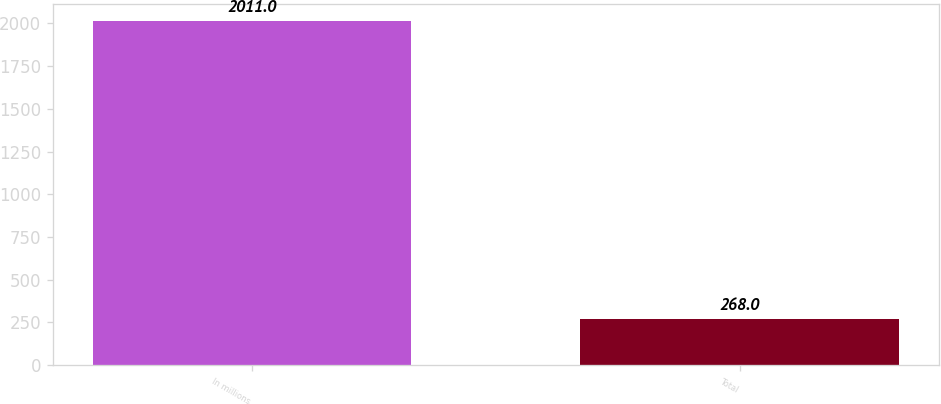Convert chart to OTSL. <chart><loc_0><loc_0><loc_500><loc_500><bar_chart><fcel>In millions<fcel>Total<nl><fcel>2011<fcel>268<nl></chart> 